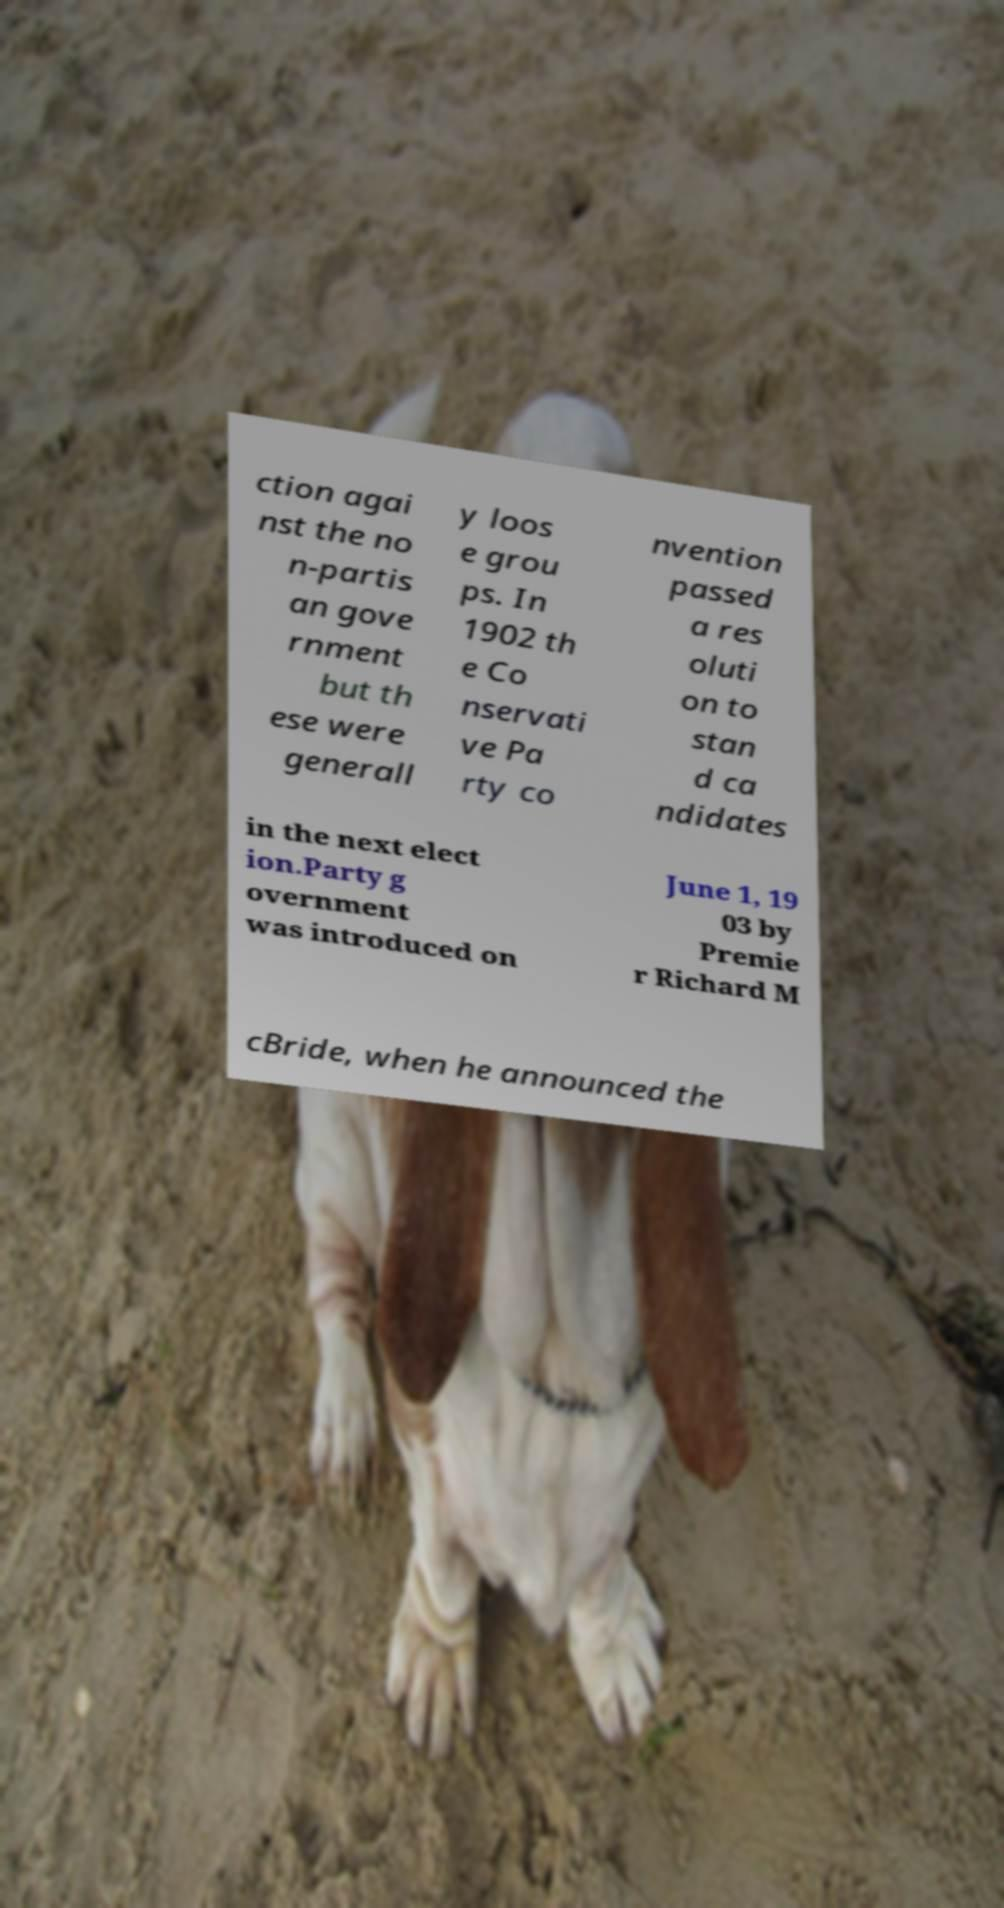Can you accurately transcribe the text from the provided image for me? ction agai nst the no n-partis an gove rnment but th ese were generall y loos e grou ps. In 1902 th e Co nservati ve Pa rty co nvention passed a res oluti on to stan d ca ndidates in the next elect ion.Party g overnment was introduced on June 1, 19 03 by Premie r Richard M cBride, when he announced the 